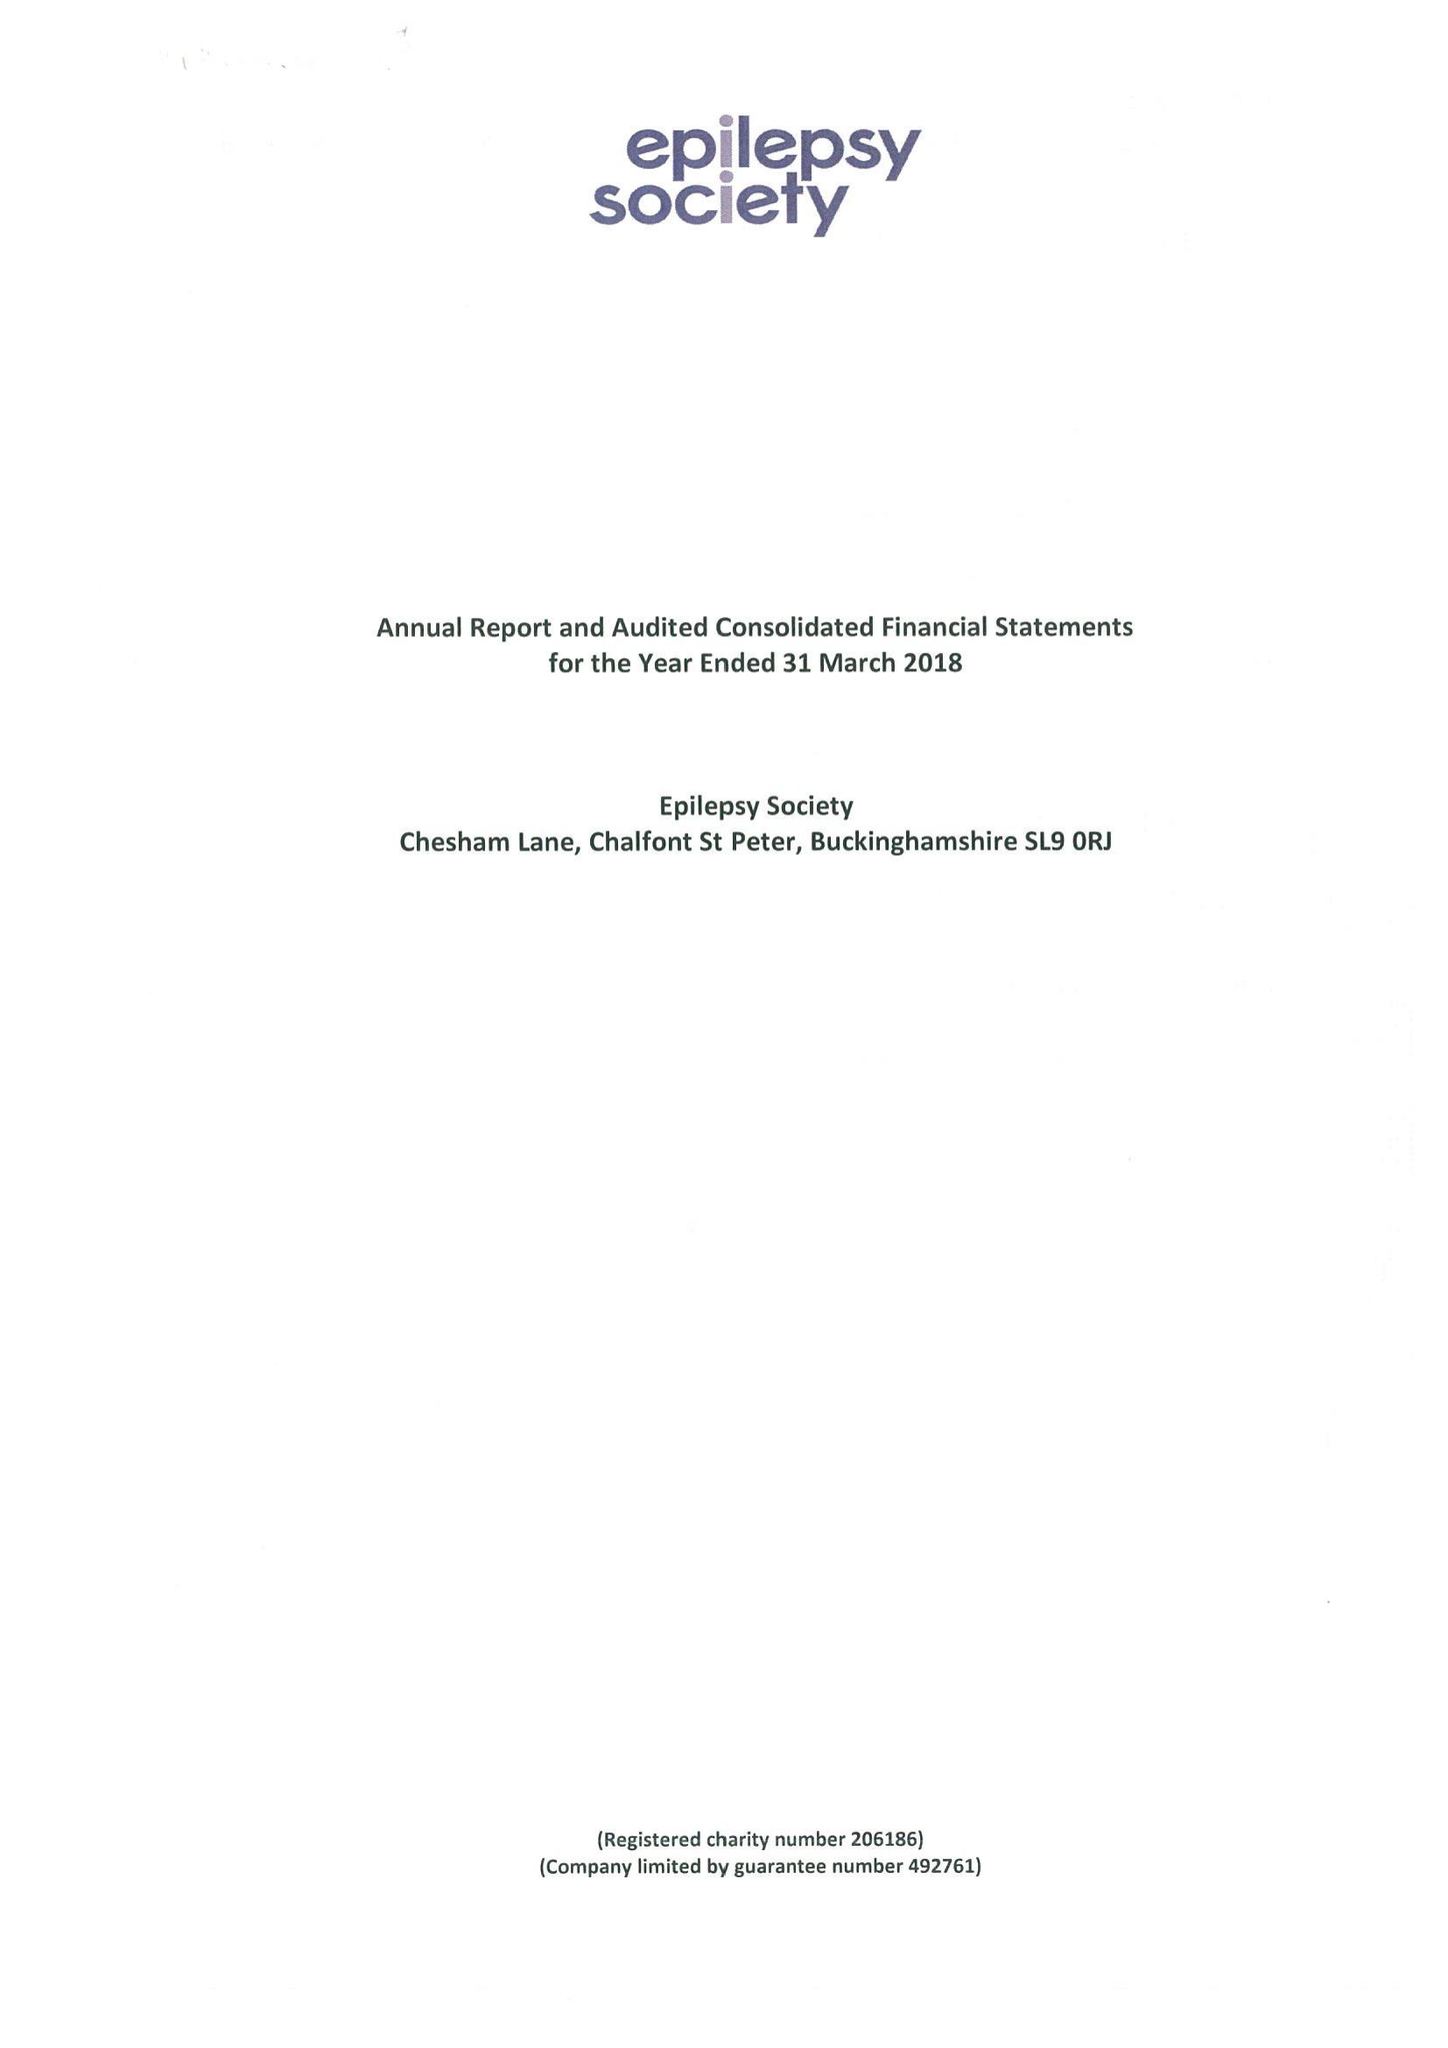What is the value for the charity_number?
Answer the question using a single word or phrase. 206186 